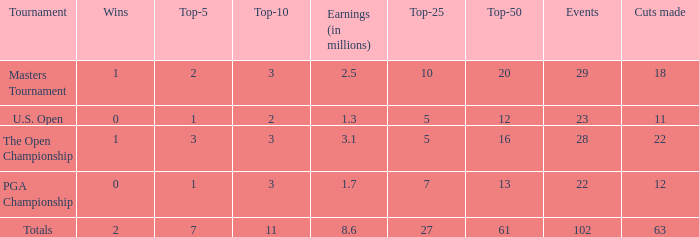How many top 10s associated with 3 top 5s and under 22 cuts made? None. 